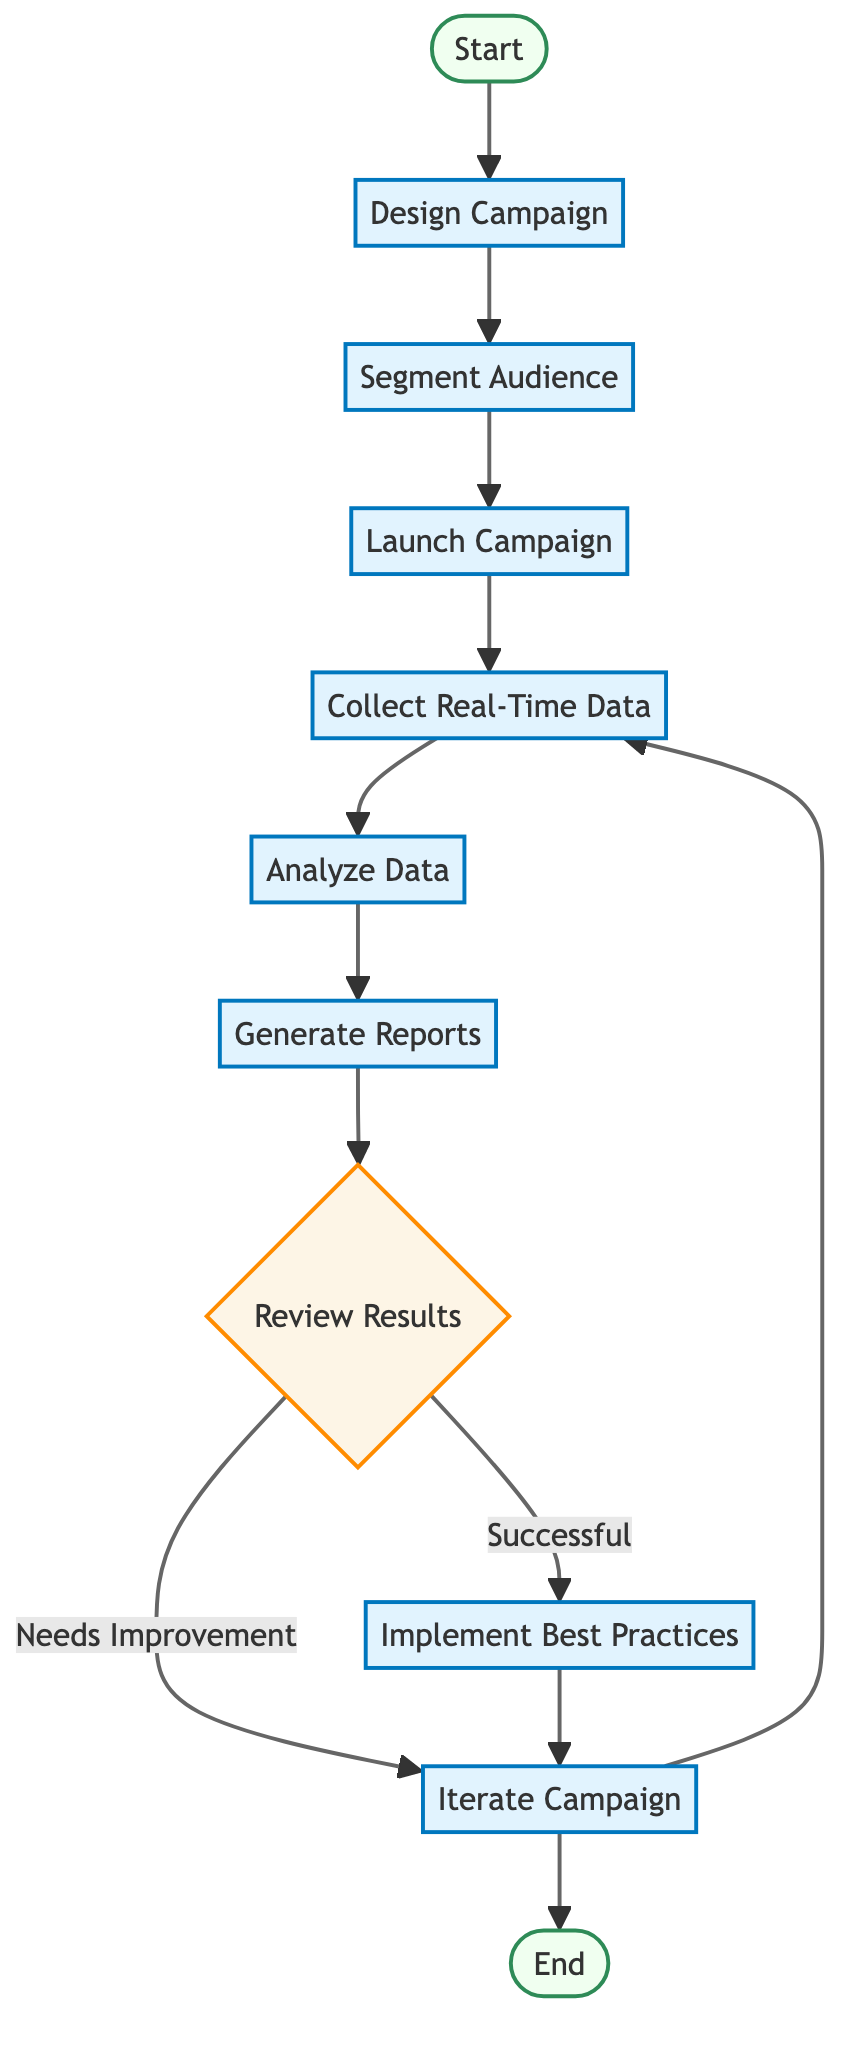What is the first step in the telemarketing campaign flow? The first node in the flowchart is labeled 'Start', indicating the initial step in the process.
Answer: Start How many processes are there in the diagram? The diagram includes six processes: Design Campaign, Segment Audience, Launch Campaign, Collect Real-Time Data, Analyze Data, and Generate Reports.
Answer: Six What decision is made after generating reports? After generating reports, the flow leads to a decision node labeled 'Review Results' to evaluate test group performance against the control group.
Answer: Review Results What is the last step in the flow? The final node in the flowchart is 'End', indicating the conclusion of the telemarketing campaign process.
Answer: End What happens if the test group's performance is successful? If the test group performs successfully as determined by the 'Review Results' node, the process moves to 'Implement Best Practices’, where successful strategies are adopted.
Answer: Implement Best Practices What is the action taken if the performance needs improvement? If the performance metrics need improvement, the flow leads to 'Iterate Campaign', where adjustments are made, and the process is repeated for optimization.
Answer: Iterate Campaign How do you collect real-time data in this flow? The collection of real-time data occurs in the 'Collect Real-Time Data' process, where metrics like call duration and conversion rates are captured.
Answer: Collect Real-Time Data What step follows the 'Analyze Data' process? Following the 'Analyze Data' process, the next step is 'Generate Reports', where actionable insights are compiled based on the analysis.
Answer: Generate Reports What is the outcome if the campaign is iterated? If the campaign is iterated, it leads back to the 'Collect Real-Time Data' process, in which subsequent data will be gathered for analysis in a continuous loop.
Answer: Collect Real-Time Data 